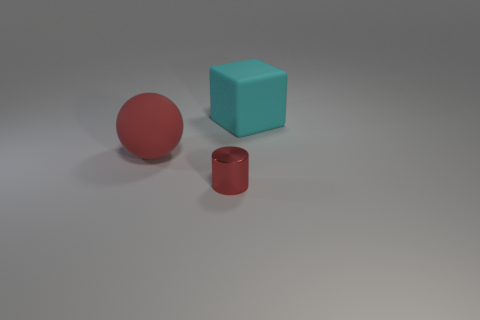Add 1 large purple shiny cylinders. How many objects exist? 4 Subtract all balls. How many objects are left? 2 Add 1 small red matte things. How many small red matte things exist? 1 Subtract 1 red cylinders. How many objects are left? 2 Subtract all big cyan matte things. Subtract all green blocks. How many objects are left? 2 Add 2 shiny cylinders. How many shiny cylinders are left? 3 